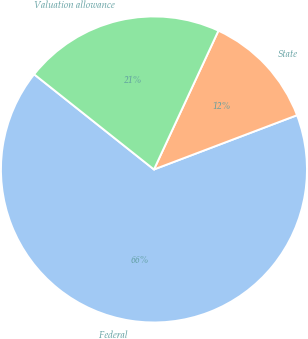<chart> <loc_0><loc_0><loc_500><loc_500><pie_chart><fcel>Federal<fcel>State<fcel>Valuation allowance<nl><fcel>66.45%<fcel>12.31%<fcel>21.24%<nl></chart> 